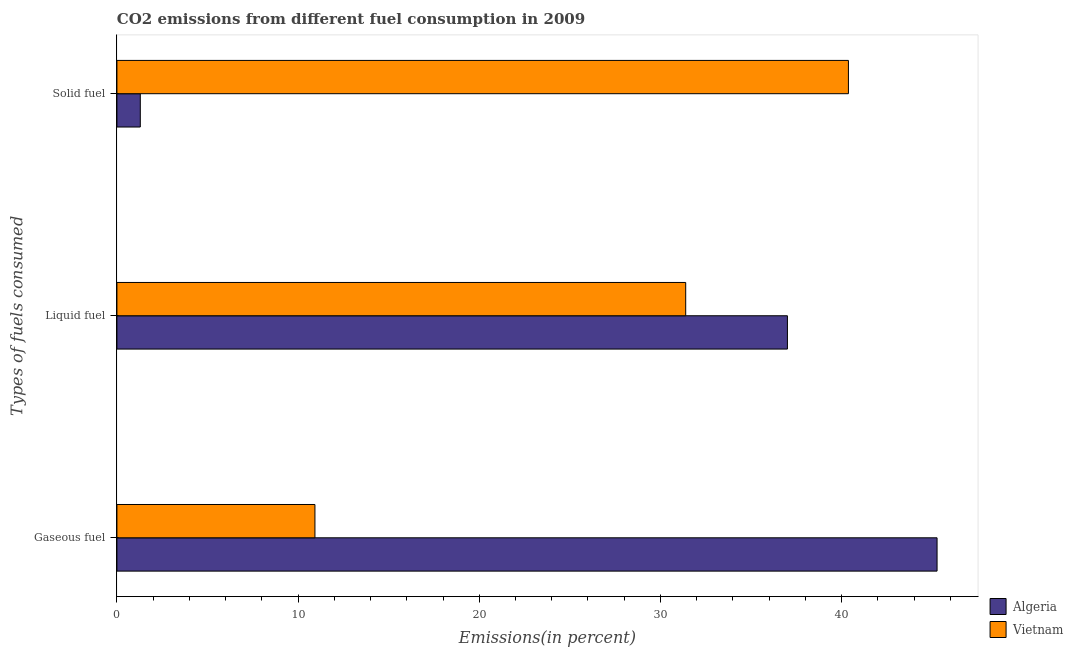How many different coloured bars are there?
Provide a short and direct response. 2. How many groups of bars are there?
Offer a terse response. 3. Are the number of bars per tick equal to the number of legend labels?
Provide a short and direct response. Yes. Are the number of bars on each tick of the Y-axis equal?
Keep it short and to the point. Yes. What is the label of the 1st group of bars from the top?
Offer a terse response. Solid fuel. What is the percentage of liquid fuel emission in Algeria?
Give a very brief answer. 37.01. Across all countries, what is the maximum percentage of liquid fuel emission?
Provide a succinct answer. 37.01. Across all countries, what is the minimum percentage of solid fuel emission?
Your answer should be very brief. 1.29. In which country was the percentage of liquid fuel emission maximum?
Your response must be concise. Algeria. In which country was the percentage of gaseous fuel emission minimum?
Your answer should be very brief. Vietnam. What is the total percentage of gaseous fuel emission in the graph?
Give a very brief answer. 56.2. What is the difference between the percentage of liquid fuel emission in Algeria and that in Vietnam?
Ensure brevity in your answer.  5.62. What is the difference between the percentage of liquid fuel emission in Vietnam and the percentage of solid fuel emission in Algeria?
Give a very brief answer. 30.11. What is the average percentage of liquid fuel emission per country?
Provide a short and direct response. 34.21. What is the difference between the percentage of gaseous fuel emission and percentage of solid fuel emission in Vietnam?
Give a very brief answer. -29.45. In how many countries, is the percentage of gaseous fuel emission greater than 6 %?
Make the answer very short. 2. What is the ratio of the percentage of liquid fuel emission in Algeria to that in Vietnam?
Provide a short and direct response. 1.18. Is the percentage of solid fuel emission in Algeria less than that in Vietnam?
Give a very brief answer. Yes. What is the difference between the highest and the second highest percentage of solid fuel emission?
Make the answer very short. 39.09. What is the difference between the highest and the lowest percentage of liquid fuel emission?
Offer a terse response. 5.62. In how many countries, is the percentage of gaseous fuel emission greater than the average percentage of gaseous fuel emission taken over all countries?
Your response must be concise. 1. Is the sum of the percentage of liquid fuel emission in Vietnam and Algeria greater than the maximum percentage of gaseous fuel emission across all countries?
Offer a terse response. Yes. What does the 2nd bar from the top in Gaseous fuel represents?
Offer a terse response. Algeria. What does the 2nd bar from the bottom in Gaseous fuel represents?
Make the answer very short. Vietnam. Is it the case that in every country, the sum of the percentage of gaseous fuel emission and percentage of liquid fuel emission is greater than the percentage of solid fuel emission?
Offer a terse response. Yes. Does the graph contain grids?
Your answer should be very brief. No. Where does the legend appear in the graph?
Your response must be concise. Bottom right. How many legend labels are there?
Ensure brevity in your answer.  2. What is the title of the graph?
Give a very brief answer. CO2 emissions from different fuel consumption in 2009. What is the label or title of the X-axis?
Keep it short and to the point. Emissions(in percent). What is the label or title of the Y-axis?
Your answer should be very brief. Types of fuels consumed. What is the Emissions(in percent) of Algeria in Gaseous fuel?
Provide a succinct answer. 45.27. What is the Emissions(in percent) of Vietnam in Gaseous fuel?
Ensure brevity in your answer.  10.93. What is the Emissions(in percent) of Algeria in Liquid fuel?
Your answer should be very brief. 37.01. What is the Emissions(in percent) of Vietnam in Liquid fuel?
Give a very brief answer. 31.4. What is the Emissions(in percent) in Algeria in Solid fuel?
Your answer should be very brief. 1.29. What is the Emissions(in percent) of Vietnam in Solid fuel?
Offer a very short reply. 40.38. Across all Types of fuels consumed, what is the maximum Emissions(in percent) of Algeria?
Provide a succinct answer. 45.27. Across all Types of fuels consumed, what is the maximum Emissions(in percent) in Vietnam?
Ensure brevity in your answer.  40.38. Across all Types of fuels consumed, what is the minimum Emissions(in percent) in Algeria?
Make the answer very short. 1.29. Across all Types of fuels consumed, what is the minimum Emissions(in percent) in Vietnam?
Provide a succinct answer. 10.93. What is the total Emissions(in percent) of Algeria in the graph?
Provide a succinct answer. 83.58. What is the total Emissions(in percent) in Vietnam in the graph?
Your answer should be very brief. 82.71. What is the difference between the Emissions(in percent) in Algeria in Gaseous fuel and that in Liquid fuel?
Provide a short and direct response. 8.26. What is the difference between the Emissions(in percent) in Vietnam in Gaseous fuel and that in Liquid fuel?
Offer a terse response. -20.47. What is the difference between the Emissions(in percent) of Algeria in Gaseous fuel and that in Solid fuel?
Offer a terse response. 43.98. What is the difference between the Emissions(in percent) of Vietnam in Gaseous fuel and that in Solid fuel?
Your response must be concise. -29.45. What is the difference between the Emissions(in percent) in Algeria in Liquid fuel and that in Solid fuel?
Offer a terse response. 35.72. What is the difference between the Emissions(in percent) in Vietnam in Liquid fuel and that in Solid fuel?
Your response must be concise. -8.98. What is the difference between the Emissions(in percent) in Algeria in Gaseous fuel and the Emissions(in percent) in Vietnam in Liquid fuel?
Your response must be concise. 13.88. What is the difference between the Emissions(in percent) in Algeria in Gaseous fuel and the Emissions(in percent) in Vietnam in Solid fuel?
Ensure brevity in your answer.  4.89. What is the difference between the Emissions(in percent) in Algeria in Liquid fuel and the Emissions(in percent) in Vietnam in Solid fuel?
Offer a terse response. -3.37. What is the average Emissions(in percent) of Algeria per Types of fuels consumed?
Your answer should be very brief. 27.86. What is the average Emissions(in percent) in Vietnam per Types of fuels consumed?
Offer a terse response. 27.57. What is the difference between the Emissions(in percent) of Algeria and Emissions(in percent) of Vietnam in Gaseous fuel?
Provide a short and direct response. 34.34. What is the difference between the Emissions(in percent) in Algeria and Emissions(in percent) in Vietnam in Liquid fuel?
Your answer should be very brief. 5.62. What is the difference between the Emissions(in percent) in Algeria and Emissions(in percent) in Vietnam in Solid fuel?
Offer a very short reply. -39.09. What is the ratio of the Emissions(in percent) of Algeria in Gaseous fuel to that in Liquid fuel?
Make the answer very short. 1.22. What is the ratio of the Emissions(in percent) of Vietnam in Gaseous fuel to that in Liquid fuel?
Your answer should be compact. 0.35. What is the ratio of the Emissions(in percent) of Algeria in Gaseous fuel to that in Solid fuel?
Your answer should be compact. 35.09. What is the ratio of the Emissions(in percent) in Vietnam in Gaseous fuel to that in Solid fuel?
Ensure brevity in your answer.  0.27. What is the ratio of the Emissions(in percent) of Algeria in Liquid fuel to that in Solid fuel?
Your answer should be compact. 28.69. What is the ratio of the Emissions(in percent) in Vietnam in Liquid fuel to that in Solid fuel?
Make the answer very short. 0.78. What is the difference between the highest and the second highest Emissions(in percent) in Algeria?
Your answer should be very brief. 8.26. What is the difference between the highest and the second highest Emissions(in percent) in Vietnam?
Your response must be concise. 8.98. What is the difference between the highest and the lowest Emissions(in percent) of Algeria?
Offer a terse response. 43.98. What is the difference between the highest and the lowest Emissions(in percent) in Vietnam?
Ensure brevity in your answer.  29.45. 